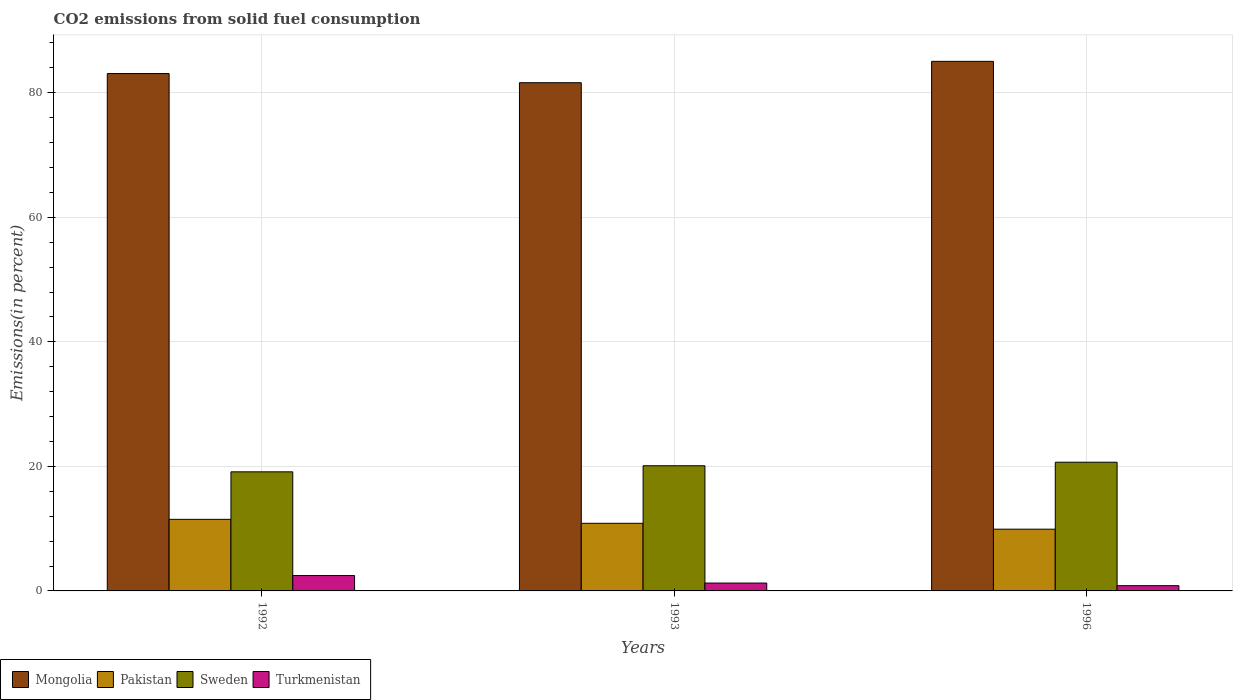How many groups of bars are there?
Provide a succinct answer. 3. Are the number of bars on each tick of the X-axis equal?
Keep it short and to the point. Yes. What is the total CO2 emitted in Sweden in 1992?
Offer a very short reply. 19.12. Across all years, what is the maximum total CO2 emitted in Sweden?
Make the answer very short. 20.67. Across all years, what is the minimum total CO2 emitted in Sweden?
Ensure brevity in your answer.  19.12. In which year was the total CO2 emitted in Pakistan maximum?
Provide a short and direct response. 1992. In which year was the total CO2 emitted in Sweden minimum?
Offer a very short reply. 1992. What is the total total CO2 emitted in Sweden in the graph?
Keep it short and to the point. 59.89. What is the difference between the total CO2 emitted in Turkmenistan in 1993 and that in 1996?
Provide a short and direct response. 0.42. What is the difference between the total CO2 emitted in Turkmenistan in 1992 and the total CO2 emitted in Mongolia in 1996?
Make the answer very short. -82.58. What is the average total CO2 emitted in Mongolia per year?
Provide a succinct answer. 83.25. In the year 1996, what is the difference between the total CO2 emitted in Pakistan and total CO2 emitted in Sweden?
Offer a terse response. -10.75. In how many years, is the total CO2 emitted in Turkmenistan greater than 84 %?
Offer a very short reply. 0. What is the ratio of the total CO2 emitted in Sweden in 1992 to that in 1996?
Your answer should be compact. 0.93. Is the total CO2 emitted in Pakistan in 1993 less than that in 1996?
Provide a succinct answer. No. What is the difference between the highest and the second highest total CO2 emitted in Turkmenistan?
Your answer should be compact. 1.2. What is the difference between the highest and the lowest total CO2 emitted in Mongolia?
Give a very brief answer. 3.43. In how many years, is the total CO2 emitted in Turkmenistan greater than the average total CO2 emitted in Turkmenistan taken over all years?
Make the answer very short. 1. Is the sum of the total CO2 emitted in Sweden in 1992 and 1993 greater than the maximum total CO2 emitted in Pakistan across all years?
Offer a very short reply. Yes. Is it the case that in every year, the sum of the total CO2 emitted in Turkmenistan and total CO2 emitted in Sweden is greater than the sum of total CO2 emitted in Pakistan and total CO2 emitted in Mongolia?
Ensure brevity in your answer.  No. Is it the case that in every year, the sum of the total CO2 emitted in Mongolia and total CO2 emitted in Pakistan is greater than the total CO2 emitted in Sweden?
Your answer should be compact. Yes. Are all the bars in the graph horizontal?
Make the answer very short. No. What is the difference between two consecutive major ticks on the Y-axis?
Keep it short and to the point. 20. Does the graph contain any zero values?
Give a very brief answer. No. How many legend labels are there?
Make the answer very short. 4. What is the title of the graph?
Your response must be concise. CO2 emissions from solid fuel consumption. Does "Paraguay" appear as one of the legend labels in the graph?
Provide a succinct answer. No. What is the label or title of the Y-axis?
Make the answer very short. Emissions(in percent). What is the Emissions(in percent) of Mongolia in 1992?
Offer a very short reply. 83.09. What is the Emissions(in percent) of Pakistan in 1992?
Offer a terse response. 11.5. What is the Emissions(in percent) of Sweden in 1992?
Make the answer very short. 19.12. What is the Emissions(in percent) of Turkmenistan in 1992?
Provide a short and direct response. 2.47. What is the Emissions(in percent) in Mongolia in 1993?
Your answer should be compact. 81.61. What is the Emissions(in percent) in Pakistan in 1993?
Keep it short and to the point. 10.86. What is the Emissions(in percent) in Sweden in 1993?
Give a very brief answer. 20.1. What is the Emissions(in percent) of Turkmenistan in 1993?
Give a very brief answer. 1.26. What is the Emissions(in percent) in Mongolia in 1996?
Give a very brief answer. 85.04. What is the Emissions(in percent) of Pakistan in 1996?
Offer a very short reply. 9.92. What is the Emissions(in percent) of Sweden in 1996?
Keep it short and to the point. 20.67. What is the Emissions(in percent) of Turkmenistan in 1996?
Make the answer very short. 0.84. Across all years, what is the maximum Emissions(in percent) of Mongolia?
Your answer should be very brief. 85.04. Across all years, what is the maximum Emissions(in percent) of Pakistan?
Your answer should be compact. 11.5. Across all years, what is the maximum Emissions(in percent) in Sweden?
Provide a short and direct response. 20.67. Across all years, what is the maximum Emissions(in percent) of Turkmenistan?
Make the answer very short. 2.47. Across all years, what is the minimum Emissions(in percent) of Mongolia?
Your response must be concise. 81.61. Across all years, what is the minimum Emissions(in percent) of Pakistan?
Make the answer very short. 9.92. Across all years, what is the minimum Emissions(in percent) in Sweden?
Your answer should be very brief. 19.12. Across all years, what is the minimum Emissions(in percent) in Turkmenistan?
Your response must be concise. 0.84. What is the total Emissions(in percent) in Mongolia in the graph?
Your answer should be very brief. 249.74. What is the total Emissions(in percent) of Pakistan in the graph?
Provide a succinct answer. 32.27. What is the total Emissions(in percent) of Sweden in the graph?
Your response must be concise. 59.89. What is the total Emissions(in percent) of Turkmenistan in the graph?
Your answer should be compact. 4.57. What is the difference between the Emissions(in percent) of Mongolia in 1992 and that in 1993?
Provide a succinct answer. 1.47. What is the difference between the Emissions(in percent) of Pakistan in 1992 and that in 1993?
Make the answer very short. 0.64. What is the difference between the Emissions(in percent) in Sweden in 1992 and that in 1993?
Your answer should be very brief. -0.98. What is the difference between the Emissions(in percent) of Turkmenistan in 1992 and that in 1993?
Your answer should be compact. 1.2. What is the difference between the Emissions(in percent) of Mongolia in 1992 and that in 1996?
Make the answer very short. -1.96. What is the difference between the Emissions(in percent) in Pakistan in 1992 and that in 1996?
Give a very brief answer. 1.58. What is the difference between the Emissions(in percent) in Sweden in 1992 and that in 1996?
Ensure brevity in your answer.  -1.54. What is the difference between the Emissions(in percent) in Turkmenistan in 1992 and that in 1996?
Provide a short and direct response. 1.63. What is the difference between the Emissions(in percent) of Mongolia in 1993 and that in 1996?
Your answer should be very brief. -3.43. What is the difference between the Emissions(in percent) of Pakistan in 1993 and that in 1996?
Your response must be concise. 0.94. What is the difference between the Emissions(in percent) in Sweden in 1993 and that in 1996?
Offer a terse response. -0.57. What is the difference between the Emissions(in percent) of Turkmenistan in 1993 and that in 1996?
Give a very brief answer. 0.42. What is the difference between the Emissions(in percent) in Mongolia in 1992 and the Emissions(in percent) in Pakistan in 1993?
Provide a succinct answer. 72.23. What is the difference between the Emissions(in percent) of Mongolia in 1992 and the Emissions(in percent) of Sweden in 1993?
Give a very brief answer. 62.98. What is the difference between the Emissions(in percent) of Mongolia in 1992 and the Emissions(in percent) of Turkmenistan in 1993?
Offer a very short reply. 81.82. What is the difference between the Emissions(in percent) in Pakistan in 1992 and the Emissions(in percent) in Sweden in 1993?
Your answer should be very brief. -8.6. What is the difference between the Emissions(in percent) of Pakistan in 1992 and the Emissions(in percent) of Turkmenistan in 1993?
Provide a succinct answer. 10.23. What is the difference between the Emissions(in percent) of Sweden in 1992 and the Emissions(in percent) of Turkmenistan in 1993?
Keep it short and to the point. 17.86. What is the difference between the Emissions(in percent) of Mongolia in 1992 and the Emissions(in percent) of Pakistan in 1996?
Keep it short and to the point. 73.17. What is the difference between the Emissions(in percent) of Mongolia in 1992 and the Emissions(in percent) of Sweden in 1996?
Your answer should be compact. 62.42. What is the difference between the Emissions(in percent) in Mongolia in 1992 and the Emissions(in percent) in Turkmenistan in 1996?
Your response must be concise. 82.24. What is the difference between the Emissions(in percent) of Pakistan in 1992 and the Emissions(in percent) of Sweden in 1996?
Ensure brevity in your answer.  -9.17. What is the difference between the Emissions(in percent) of Pakistan in 1992 and the Emissions(in percent) of Turkmenistan in 1996?
Provide a succinct answer. 10.65. What is the difference between the Emissions(in percent) in Sweden in 1992 and the Emissions(in percent) in Turkmenistan in 1996?
Your response must be concise. 18.28. What is the difference between the Emissions(in percent) of Mongolia in 1993 and the Emissions(in percent) of Pakistan in 1996?
Ensure brevity in your answer.  71.7. What is the difference between the Emissions(in percent) of Mongolia in 1993 and the Emissions(in percent) of Sweden in 1996?
Offer a terse response. 60.95. What is the difference between the Emissions(in percent) of Mongolia in 1993 and the Emissions(in percent) of Turkmenistan in 1996?
Offer a very short reply. 80.77. What is the difference between the Emissions(in percent) in Pakistan in 1993 and the Emissions(in percent) in Sweden in 1996?
Make the answer very short. -9.81. What is the difference between the Emissions(in percent) in Pakistan in 1993 and the Emissions(in percent) in Turkmenistan in 1996?
Your answer should be compact. 10.02. What is the difference between the Emissions(in percent) of Sweden in 1993 and the Emissions(in percent) of Turkmenistan in 1996?
Ensure brevity in your answer.  19.26. What is the average Emissions(in percent) of Mongolia per year?
Keep it short and to the point. 83.25. What is the average Emissions(in percent) in Pakistan per year?
Ensure brevity in your answer.  10.76. What is the average Emissions(in percent) in Sweden per year?
Keep it short and to the point. 19.96. What is the average Emissions(in percent) in Turkmenistan per year?
Offer a very short reply. 1.52. In the year 1992, what is the difference between the Emissions(in percent) in Mongolia and Emissions(in percent) in Pakistan?
Offer a terse response. 71.59. In the year 1992, what is the difference between the Emissions(in percent) of Mongolia and Emissions(in percent) of Sweden?
Provide a short and direct response. 63.96. In the year 1992, what is the difference between the Emissions(in percent) of Mongolia and Emissions(in percent) of Turkmenistan?
Your response must be concise. 80.62. In the year 1992, what is the difference between the Emissions(in percent) in Pakistan and Emissions(in percent) in Sweden?
Your response must be concise. -7.63. In the year 1992, what is the difference between the Emissions(in percent) of Pakistan and Emissions(in percent) of Turkmenistan?
Provide a succinct answer. 9.03. In the year 1992, what is the difference between the Emissions(in percent) in Sweden and Emissions(in percent) in Turkmenistan?
Offer a very short reply. 16.66. In the year 1993, what is the difference between the Emissions(in percent) in Mongolia and Emissions(in percent) in Pakistan?
Make the answer very short. 70.76. In the year 1993, what is the difference between the Emissions(in percent) in Mongolia and Emissions(in percent) in Sweden?
Ensure brevity in your answer.  61.51. In the year 1993, what is the difference between the Emissions(in percent) in Mongolia and Emissions(in percent) in Turkmenistan?
Make the answer very short. 80.35. In the year 1993, what is the difference between the Emissions(in percent) of Pakistan and Emissions(in percent) of Sweden?
Your answer should be very brief. -9.24. In the year 1993, what is the difference between the Emissions(in percent) in Pakistan and Emissions(in percent) in Turkmenistan?
Give a very brief answer. 9.6. In the year 1993, what is the difference between the Emissions(in percent) in Sweden and Emissions(in percent) in Turkmenistan?
Provide a succinct answer. 18.84. In the year 1996, what is the difference between the Emissions(in percent) in Mongolia and Emissions(in percent) in Pakistan?
Make the answer very short. 75.13. In the year 1996, what is the difference between the Emissions(in percent) of Mongolia and Emissions(in percent) of Sweden?
Keep it short and to the point. 64.38. In the year 1996, what is the difference between the Emissions(in percent) in Mongolia and Emissions(in percent) in Turkmenistan?
Offer a very short reply. 84.2. In the year 1996, what is the difference between the Emissions(in percent) in Pakistan and Emissions(in percent) in Sweden?
Provide a succinct answer. -10.75. In the year 1996, what is the difference between the Emissions(in percent) in Pakistan and Emissions(in percent) in Turkmenistan?
Keep it short and to the point. 9.07. In the year 1996, what is the difference between the Emissions(in percent) in Sweden and Emissions(in percent) in Turkmenistan?
Offer a terse response. 19.82. What is the ratio of the Emissions(in percent) of Mongolia in 1992 to that in 1993?
Offer a very short reply. 1.02. What is the ratio of the Emissions(in percent) of Pakistan in 1992 to that in 1993?
Your answer should be very brief. 1.06. What is the ratio of the Emissions(in percent) of Sweden in 1992 to that in 1993?
Offer a very short reply. 0.95. What is the ratio of the Emissions(in percent) of Turkmenistan in 1992 to that in 1993?
Ensure brevity in your answer.  1.95. What is the ratio of the Emissions(in percent) of Pakistan in 1992 to that in 1996?
Ensure brevity in your answer.  1.16. What is the ratio of the Emissions(in percent) of Sweden in 1992 to that in 1996?
Offer a terse response. 0.93. What is the ratio of the Emissions(in percent) in Turkmenistan in 1992 to that in 1996?
Ensure brevity in your answer.  2.93. What is the ratio of the Emissions(in percent) in Mongolia in 1993 to that in 1996?
Your answer should be very brief. 0.96. What is the ratio of the Emissions(in percent) in Pakistan in 1993 to that in 1996?
Make the answer very short. 1.1. What is the ratio of the Emissions(in percent) of Sweden in 1993 to that in 1996?
Provide a short and direct response. 0.97. What is the ratio of the Emissions(in percent) in Turkmenistan in 1993 to that in 1996?
Make the answer very short. 1.5. What is the difference between the highest and the second highest Emissions(in percent) in Mongolia?
Provide a succinct answer. 1.96. What is the difference between the highest and the second highest Emissions(in percent) in Pakistan?
Offer a very short reply. 0.64. What is the difference between the highest and the second highest Emissions(in percent) of Sweden?
Your answer should be very brief. 0.57. What is the difference between the highest and the second highest Emissions(in percent) of Turkmenistan?
Offer a very short reply. 1.2. What is the difference between the highest and the lowest Emissions(in percent) in Mongolia?
Ensure brevity in your answer.  3.43. What is the difference between the highest and the lowest Emissions(in percent) of Pakistan?
Provide a succinct answer. 1.58. What is the difference between the highest and the lowest Emissions(in percent) in Sweden?
Give a very brief answer. 1.54. What is the difference between the highest and the lowest Emissions(in percent) of Turkmenistan?
Keep it short and to the point. 1.63. 